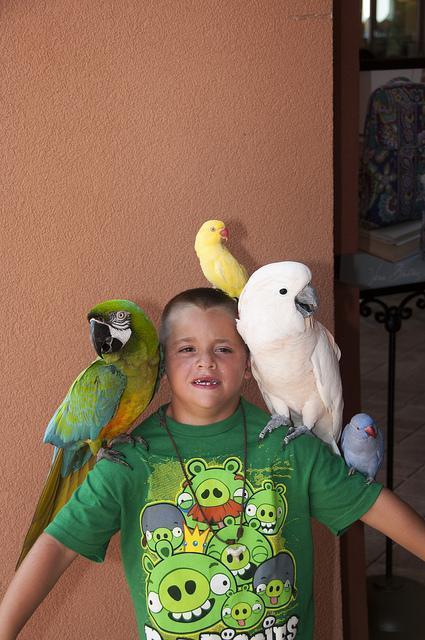How many birds are visible?
Give a very brief answer. 4. 